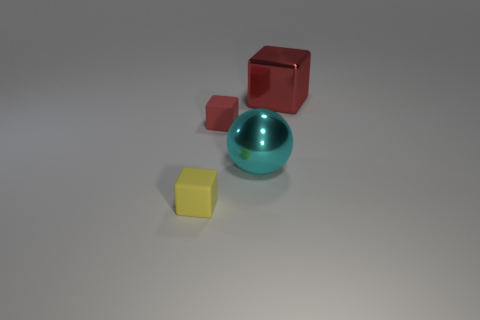Is the big thing left of the red metallic object made of the same material as the small object behind the yellow rubber block?
Your answer should be very brief. No. The red thing that is behind the matte object that is behind the sphere is made of what material?
Keep it short and to the point. Metal. How big is the metallic thing that is in front of the large object that is behind the matte thing that is to the right of the yellow object?
Your answer should be compact. Large. Is the cyan thing the same size as the yellow cube?
Provide a succinct answer. No. There is a large metal object in front of the red shiny thing; is it the same shape as the small object that is on the right side of the small yellow thing?
Make the answer very short. No. Are there any cyan shiny things that are left of the matte object to the right of the small yellow cube?
Give a very brief answer. No. Is there a big red shiny object?
Make the answer very short. Yes. What number of metallic things are the same size as the sphere?
Keep it short and to the point. 1. What number of large shiny things are both behind the big cyan shiny ball and in front of the big cube?
Your response must be concise. 0. There is a block that is behind the red rubber object; is its size the same as the large cyan shiny ball?
Offer a terse response. Yes. 